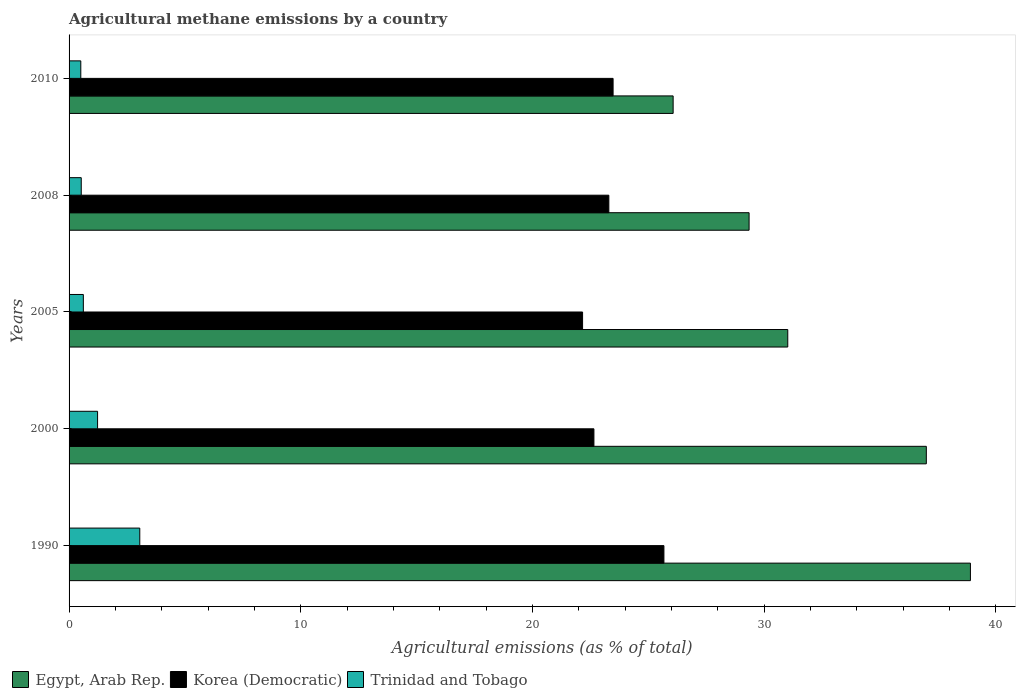Are the number of bars per tick equal to the number of legend labels?
Your answer should be compact. Yes. How many bars are there on the 2nd tick from the bottom?
Your answer should be very brief. 3. What is the amount of agricultural methane emitted in Egypt, Arab Rep. in 2010?
Ensure brevity in your answer.  26.07. Across all years, what is the maximum amount of agricultural methane emitted in Trinidad and Tobago?
Keep it short and to the point. 3.05. Across all years, what is the minimum amount of agricultural methane emitted in Korea (Democratic)?
Keep it short and to the point. 22.16. What is the total amount of agricultural methane emitted in Egypt, Arab Rep. in the graph?
Make the answer very short. 162.35. What is the difference between the amount of agricultural methane emitted in Korea (Democratic) in 2008 and that in 2010?
Ensure brevity in your answer.  -0.18. What is the difference between the amount of agricultural methane emitted in Korea (Democratic) in 1990 and the amount of agricultural methane emitted in Egypt, Arab Rep. in 2010?
Keep it short and to the point. -0.4. What is the average amount of agricultural methane emitted in Egypt, Arab Rep. per year?
Provide a succinct answer. 32.47. In the year 1990, what is the difference between the amount of agricultural methane emitted in Korea (Democratic) and amount of agricultural methane emitted in Trinidad and Tobago?
Provide a succinct answer. 22.62. What is the ratio of the amount of agricultural methane emitted in Egypt, Arab Rep. in 1990 to that in 2010?
Offer a terse response. 1.49. What is the difference between the highest and the second highest amount of agricultural methane emitted in Korea (Democratic)?
Keep it short and to the point. 2.19. What is the difference between the highest and the lowest amount of agricultural methane emitted in Korea (Democratic)?
Your response must be concise. 3.51. Is the sum of the amount of agricultural methane emitted in Korea (Democratic) in 1990 and 2008 greater than the maximum amount of agricultural methane emitted in Egypt, Arab Rep. across all years?
Provide a succinct answer. Yes. What does the 1st bar from the top in 2000 represents?
Your response must be concise. Trinidad and Tobago. What does the 2nd bar from the bottom in 2010 represents?
Keep it short and to the point. Korea (Democratic). How many bars are there?
Provide a succinct answer. 15. How many years are there in the graph?
Provide a short and direct response. 5. Are the values on the major ticks of X-axis written in scientific E-notation?
Provide a succinct answer. No. Does the graph contain any zero values?
Ensure brevity in your answer.  No. Does the graph contain grids?
Your response must be concise. No. What is the title of the graph?
Give a very brief answer. Agricultural methane emissions by a country. What is the label or title of the X-axis?
Make the answer very short. Agricultural emissions (as % of total). What is the Agricultural emissions (as % of total) in Egypt, Arab Rep. in 1990?
Provide a succinct answer. 38.9. What is the Agricultural emissions (as % of total) of Korea (Democratic) in 1990?
Ensure brevity in your answer.  25.68. What is the Agricultural emissions (as % of total) of Trinidad and Tobago in 1990?
Your answer should be very brief. 3.05. What is the Agricultural emissions (as % of total) of Egypt, Arab Rep. in 2000?
Offer a very short reply. 37. What is the Agricultural emissions (as % of total) in Korea (Democratic) in 2000?
Make the answer very short. 22.65. What is the Agricultural emissions (as % of total) of Trinidad and Tobago in 2000?
Your answer should be very brief. 1.23. What is the Agricultural emissions (as % of total) in Egypt, Arab Rep. in 2005?
Provide a short and direct response. 31.02. What is the Agricultural emissions (as % of total) of Korea (Democratic) in 2005?
Provide a short and direct response. 22.16. What is the Agricultural emissions (as % of total) in Trinidad and Tobago in 2005?
Keep it short and to the point. 0.62. What is the Agricultural emissions (as % of total) in Egypt, Arab Rep. in 2008?
Provide a short and direct response. 29.35. What is the Agricultural emissions (as % of total) of Korea (Democratic) in 2008?
Offer a very short reply. 23.3. What is the Agricultural emissions (as % of total) in Trinidad and Tobago in 2008?
Offer a terse response. 0.53. What is the Agricultural emissions (as % of total) in Egypt, Arab Rep. in 2010?
Your answer should be very brief. 26.07. What is the Agricultural emissions (as % of total) of Korea (Democratic) in 2010?
Give a very brief answer. 23.48. What is the Agricultural emissions (as % of total) of Trinidad and Tobago in 2010?
Offer a terse response. 0.51. Across all years, what is the maximum Agricultural emissions (as % of total) in Egypt, Arab Rep.?
Ensure brevity in your answer.  38.9. Across all years, what is the maximum Agricultural emissions (as % of total) in Korea (Democratic)?
Make the answer very short. 25.68. Across all years, what is the maximum Agricultural emissions (as % of total) of Trinidad and Tobago?
Give a very brief answer. 3.05. Across all years, what is the minimum Agricultural emissions (as % of total) of Egypt, Arab Rep.?
Offer a terse response. 26.07. Across all years, what is the minimum Agricultural emissions (as % of total) of Korea (Democratic)?
Make the answer very short. 22.16. Across all years, what is the minimum Agricultural emissions (as % of total) in Trinidad and Tobago?
Your answer should be very brief. 0.51. What is the total Agricultural emissions (as % of total) of Egypt, Arab Rep. in the graph?
Provide a succinct answer. 162.35. What is the total Agricultural emissions (as % of total) of Korea (Democratic) in the graph?
Your response must be concise. 117.27. What is the total Agricultural emissions (as % of total) of Trinidad and Tobago in the graph?
Your answer should be compact. 5.93. What is the difference between the Agricultural emissions (as % of total) of Egypt, Arab Rep. in 1990 and that in 2000?
Make the answer very short. 1.9. What is the difference between the Agricultural emissions (as % of total) in Korea (Democratic) in 1990 and that in 2000?
Offer a terse response. 3.02. What is the difference between the Agricultural emissions (as % of total) in Trinidad and Tobago in 1990 and that in 2000?
Provide a succinct answer. 1.82. What is the difference between the Agricultural emissions (as % of total) of Egypt, Arab Rep. in 1990 and that in 2005?
Make the answer very short. 7.88. What is the difference between the Agricultural emissions (as % of total) in Korea (Democratic) in 1990 and that in 2005?
Make the answer very short. 3.51. What is the difference between the Agricultural emissions (as % of total) in Trinidad and Tobago in 1990 and that in 2005?
Offer a very short reply. 2.44. What is the difference between the Agricultural emissions (as % of total) of Egypt, Arab Rep. in 1990 and that in 2008?
Ensure brevity in your answer.  9.55. What is the difference between the Agricultural emissions (as % of total) of Korea (Democratic) in 1990 and that in 2008?
Give a very brief answer. 2.38. What is the difference between the Agricultural emissions (as % of total) in Trinidad and Tobago in 1990 and that in 2008?
Your answer should be compact. 2.53. What is the difference between the Agricultural emissions (as % of total) in Egypt, Arab Rep. in 1990 and that in 2010?
Keep it short and to the point. 12.83. What is the difference between the Agricultural emissions (as % of total) in Korea (Democratic) in 1990 and that in 2010?
Your answer should be compact. 2.19. What is the difference between the Agricultural emissions (as % of total) of Trinidad and Tobago in 1990 and that in 2010?
Provide a short and direct response. 2.55. What is the difference between the Agricultural emissions (as % of total) of Egypt, Arab Rep. in 2000 and that in 2005?
Your response must be concise. 5.98. What is the difference between the Agricultural emissions (as % of total) of Korea (Democratic) in 2000 and that in 2005?
Offer a terse response. 0.49. What is the difference between the Agricultural emissions (as % of total) of Trinidad and Tobago in 2000 and that in 2005?
Provide a succinct answer. 0.61. What is the difference between the Agricultural emissions (as % of total) of Egypt, Arab Rep. in 2000 and that in 2008?
Your answer should be compact. 7.65. What is the difference between the Agricultural emissions (as % of total) in Korea (Democratic) in 2000 and that in 2008?
Provide a short and direct response. -0.64. What is the difference between the Agricultural emissions (as % of total) of Trinidad and Tobago in 2000 and that in 2008?
Offer a very short reply. 0.7. What is the difference between the Agricultural emissions (as % of total) in Egypt, Arab Rep. in 2000 and that in 2010?
Make the answer very short. 10.93. What is the difference between the Agricultural emissions (as % of total) in Korea (Democratic) in 2000 and that in 2010?
Provide a succinct answer. -0.83. What is the difference between the Agricultural emissions (as % of total) in Trinidad and Tobago in 2000 and that in 2010?
Offer a terse response. 0.72. What is the difference between the Agricultural emissions (as % of total) in Egypt, Arab Rep. in 2005 and that in 2008?
Keep it short and to the point. 1.67. What is the difference between the Agricultural emissions (as % of total) of Korea (Democratic) in 2005 and that in 2008?
Provide a succinct answer. -1.13. What is the difference between the Agricultural emissions (as % of total) of Trinidad and Tobago in 2005 and that in 2008?
Keep it short and to the point. 0.09. What is the difference between the Agricultural emissions (as % of total) in Egypt, Arab Rep. in 2005 and that in 2010?
Offer a terse response. 4.95. What is the difference between the Agricultural emissions (as % of total) in Korea (Democratic) in 2005 and that in 2010?
Ensure brevity in your answer.  -1.32. What is the difference between the Agricultural emissions (as % of total) in Trinidad and Tobago in 2005 and that in 2010?
Offer a very short reply. 0.11. What is the difference between the Agricultural emissions (as % of total) of Egypt, Arab Rep. in 2008 and that in 2010?
Make the answer very short. 3.28. What is the difference between the Agricultural emissions (as % of total) in Korea (Democratic) in 2008 and that in 2010?
Your answer should be very brief. -0.18. What is the difference between the Agricultural emissions (as % of total) in Trinidad and Tobago in 2008 and that in 2010?
Make the answer very short. 0.02. What is the difference between the Agricultural emissions (as % of total) of Egypt, Arab Rep. in 1990 and the Agricultural emissions (as % of total) of Korea (Democratic) in 2000?
Provide a succinct answer. 16.25. What is the difference between the Agricultural emissions (as % of total) of Egypt, Arab Rep. in 1990 and the Agricultural emissions (as % of total) of Trinidad and Tobago in 2000?
Provide a short and direct response. 37.67. What is the difference between the Agricultural emissions (as % of total) of Korea (Democratic) in 1990 and the Agricultural emissions (as % of total) of Trinidad and Tobago in 2000?
Ensure brevity in your answer.  24.44. What is the difference between the Agricultural emissions (as % of total) in Egypt, Arab Rep. in 1990 and the Agricultural emissions (as % of total) in Korea (Democratic) in 2005?
Your answer should be compact. 16.74. What is the difference between the Agricultural emissions (as % of total) in Egypt, Arab Rep. in 1990 and the Agricultural emissions (as % of total) in Trinidad and Tobago in 2005?
Keep it short and to the point. 38.29. What is the difference between the Agricultural emissions (as % of total) of Korea (Democratic) in 1990 and the Agricultural emissions (as % of total) of Trinidad and Tobago in 2005?
Offer a terse response. 25.06. What is the difference between the Agricultural emissions (as % of total) of Egypt, Arab Rep. in 1990 and the Agricultural emissions (as % of total) of Korea (Democratic) in 2008?
Your response must be concise. 15.61. What is the difference between the Agricultural emissions (as % of total) of Egypt, Arab Rep. in 1990 and the Agricultural emissions (as % of total) of Trinidad and Tobago in 2008?
Your answer should be very brief. 38.38. What is the difference between the Agricultural emissions (as % of total) of Korea (Democratic) in 1990 and the Agricultural emissions (as % of total) of Trinidad and Tobago in 2008?
Offer a very short reply. 25.15. What is the difference between the Agricultural emissions (as % of total) of Egypt, Arab Rep. in 1990 and the Agricultural emissions (as % of total) of Korea (Democratic) in 2010?
Provide a short and direct response. 15.42. What is the difference between the Agricultural emissions (as % of total) of Egypt, Arab Rep. in 1990 and the Agricultural emissions (as % of total) of Trinidad and Tobago in 2010?
Keep it short and to the point. 38.4. What is the difference between the Agricultural emissions (as % of total) of Korea (Democratic) in 1990 and the Agricultural emissions (as % of total) of Trinidad and Tobago in 2010?
Provide a short and direct response. 25.17. What is the difference between the Agricultural emissions (as % of total) of Egypt, Arab Rep. in 2000 and the Agricultural emissions (as % of total) of Korea (Democratic) in 2005?
Offer a very short reply. 14.84. What is the difference between the Agricultural emissions (as % of total) in Egypt, Arab Rep. in 2000 and the Agricultural emissions (as % of total) in Trinidad and Tobago in 2005?
Make the answer very short. 36.38. What is the difference between the Agricultural emissions (as % of total) in Korea (Democratic) in 2000 and the Agricultural emissions (as % of total) in Trinidad and Tobago in 2005?
Ensure brevity in your answer.  22.04. What is the difference between the Agricultural emissions (as % of total) in Egypt, Arab Rep. in 2000 and the Agricultural emissions (as % of total) in Korea (Democratic) in 2008?
Provide a succinct answer. 13.7. What is the difference between the Agricultural emissions (as % of total) in Egypt, Arab Rep. in 2000 and the Agricultural emissions (as % of total) in Trinidad and Tobago in 2008?
Your response must be concise. 36.48. What is the difference between the Agricultural emissions (as % of total) in Korea (Democratic) in 2000 and the Agricultural emissions (as % of total) in Trinidad and Tobago in 2008?
Offer a terse response. 22.13. What is the difference between the Agricultural emissions (as % of total) of Egypt, Arab Rep. in 2000 and the Agricultural emissions (as % of total) of Korea (Democratic) in 2010?
Provide a short and direct response. 13.52. What is the difference between the Agricultural emissions (as % of total) in Egypt, Arab Rep. in 2000 and the Agricultural emissions (as % of total) in Trinidad and Tobago in 2010?
Offer a terse response. 36.49. What is the difference between the Agricultural emissions (as % of total) in Korea (Democratic) in 2000 and the Agricultural emissions (as % of total) in Trinidad and Tobago in 2010?
Provide a succinct answer. 22.15. What is the difference between the Agricultural emissions (as % of total) in Egypt, Arab Rep. in 2005 and the Agricultural emissions (as % of total) in Korea (Democratic) in 2008?
Make the answer very short. 7.72. What is the difference between the Agricultural emissions (as % of total) in Egypt, Arab Rep. in 2005 and the Agricultural emissions (as % of total) in Trinidad and Tobago in 2008?
Ensure brevity in your answer.  30.49. What is the difference between the Agricultural emissions (as % of total) in Korea (Democratic) in 2005 and the Agricultural emissions (as % of total) in Trinidad and Tobago in 2008?
Your answer should be very brief. 21.64. What is the difference between the Agricultural emissions (as % of total) in Egypt, Arab Rep. in 2005 and the Agricultural emissions (as % of total) in Korea (Democratic) in 2010?
Give a very brief answer. 7.54. What is the difference between the Agricultural emissions (as % of total) in Egypt, Arab Rep. in 2005 and the Agricultural emissions (as % of total) in Trinidad and Tobago in 2010?
Ensure brevity in your answer.  30.51. What is the difference between the Agricultural emissions (as % of total) of Korea (Democratic) in 2005 and the Agricultural emissions (as % of total) of Trinidad and Tobago in 2010?
Offer a terse response. 21.66. What is the difference between the Agricultural emissions (as % of total) in Egypt, Arab Rep. in 2008 and the Agricultural emissions (as % of total) in Korea (Democratic) in 2010?
Keep it short and to the point. 5.87. What is the difference between the Agricultural emissions (as % of total) in Egypt, Arab Rep. in 2008 and the Agricultural emissions (as % of total) in Trinidad and Tobago in 2010?
Provide a short and direct response. 28.84. What is the difference between the Agricultural emissions (as % of total) in Korea (Democratic) in 2008 and the Agricultural emissions (as % of total) in Trinidad and Tobago in 2010?
Your answer should be very brief. 22.79. What is the average Agricultural emissions (as % of total) in Egypt, Arab Rep. per year?
Your response must be concise. 32.47. What is the average Agricultural emissions (as % of total) in Korea (Democratic) per year?
Make the answer very short. 23.45. What is the average Agricultural emissions (as % of total) of Trinidad and Tobago per year?
Provide a succinct answer. 1.19. In the year 1990, what is the difference between the Agricultural emissions (as % of total) of Egypt, Arab Rep. and Agricultural emissions (as % of total) of Korea (Democratic)?
Your answer should be compact. 13.23. In the year 1990, what is the difference between the Agricultural emissions (as % of total) of Egypt, Arab Rep. and Agricultural emissions (as % of total) of Trinidad and Tobago?
Give a very brief answer. 35.85. In the year 1990, what is the difference between the Agricultural emissions (as % of total) of Korea (Democratic) and Agricultural emissions (as % of total) of Trinidad and Tobago?
Provide a short and direct response. 22.62. In the year 2000, what is the difference between the Agricultural emissions (as % of total) of Egypt, Arab Rep. and Agricultural emissions (as % of total) of Korea (Democratic)?
Make the answer very short. 14.35. In the year 2000, what is the difference between the Agricultural emissions (as % of total) of Egypt, Arab Rep. and Agricultural emissions (as % of total) of Trinidad and Tobago?
Offer a very short reply. 35.77. In the year 2000, what is the difference between the Agricultural emissions (as % of total) in Korea (Democratic) and Agricultural emissions (as % of total) in Trinidad and Tobago?
Keep it short and to the point. 21.42. In the year 2005, what is the difference between the Agricultural emissions (as % of total) of Egypt, Arab Rep. and Agricultural emissions (as % of total) of Korea (Democratic)?
Give a very brief answer. 8.86. In the year 2005, what is the difference between the Agricultural emissions (as % of total) in Egypt, Arab Rep. and Agricultural emissions (as % of total) in Trinidad and Tobago?
Your answer should be compact. 30.4. In the year 2005, what is the difference between the Agricultural emissions (as % of total) in Korea (Democratic) and Agricultural emissions (as % of total) in Trinidad and Tobago?
Your answer should be very brief. 21.55. In the year 2008, what is the difference between the Agricultural emissions (as % of total) in Egypt, Arab Rep. and Agricultural emissions (as % of total) in Korea (Democratic)?
Provide a short and direct response. 6.05. In the year 2008, what is the difference between the Agricultural emissions (as % of total) of Egypt, Arab Rep. and Agricultural emissions (as % of total) of Trinidad and Tobago?
Provide a succinct answer. 28.83. In the year 2008, what is the difference between the Agricultural emissions (as % of total) of Korea (Democratic) and Agricultural emissions (as % of total) of Trinidad and Tobago?
Your answer should be very brief. 22.77. In the year 2010, what is the difference between the Agricultural emissions (as % of total) of Egypt, Arab Rep. and Agricultural emissions (as % of total) of Korea (Democratic)?
Offer a terse response. 2.59. In the year 2010, what is the difference between the Agricultural emissions (as % of total) in Egypt, Arab Rep. and Agricultural emissions (as % of total) in Trinidad and Tobago?
Ensure brevity in your answer.  25.57. In the year 2010, what is the difference between the Agricultural emissions (as % of total) of Korea (Democratic) and Agricultural emissions (as % of total) of Trinidad and Tobago?
Keep it short and to the point. 22.97. What is the ratio of the Agricultural emissions (as % of total) of Egypt, Arab Rep. in 1990 to that in 2000?
Give a very brief answer. 1.05. What is the ratio of the Agricultural emissions (as % of total) in Korea (Democratic) in 1990 to that in 2000?
Ensure brevity in your answer.  1.13. What is the ratio of the Agricultural emissions (as % of total) of Trinidad and Tobago in 1990 to that in 2000?
Keep it short and to the point. 2.48. What is the ratio of the Agricultural emissions (as % of total) of Egypt, Arab Rep. in 1990 to that in 2005?
Your answer should be compact. 1.25. What is the ratio of the Agricultural emissions (as % of total) in Korea (Democratic) in 1990 to that in 2005?
Your answer should be compact. 1.16. What is the ratio of the Agricultural emissions (as % of total) of Trinidad and Tobago in 1990 to that in 2005?
Your response must be concise. 4.95. What is the ratio of the Agricultural emissions (as % of total) in Egypt, Arab Rep. in 1990 to that in 2008?
Your answer should be compact. 1.33. What is the ratio of the Agricultural emissions (as % of total) in Korea (Democratic) in 1990 to that in 2008?
Your answer should be very brief. 1.1. What is the ratio of the Agricultural emissions (as % of total) in Trinidad and Tobago in 1990 to that in 2008?
Provide a short and direct response. 5.81. What is the ratio of the Agricultural emissions (as % of total) of Egypt, Arab Rep. in 1990 to that in 2010?
Keep it short and to the point. 1.49. What is the ratio of the Agricultural emissions (as % of total) in Korea (Democratic) in 1990 to that in 2010?
Make the answer very short. 1.09. What is the ratio of the Agricultural emissions (as % of total) of Trinidad and Tobago in 1990 to that in 2010?
Keep it short and to the point. 6.03. What is the ratio of the Agricultural emissions (as % of total) of Egypt, Arab Rep. in 2000 to that in 2005?
Your answer should be compact. 1.19. What is the ratio of the Agricultural emissions (as % of total) of Korea (Democratic) in 2000 to that in 2005?
Make the answer very short. 1.02. What is the ratio of the Agricultural emissions (as % of total) in Trinidad and Tobago in 2000 to that in 2005?
Your response must be concise. 2. What is the ratio of the Agricultural emissions (as % of total) in Egypt, Arab Rep. in 2000 to that in 2008?
Your answer should be very brief. 1.26. What is the ratio of the Agricultural emissions (as % of total) in Korea (Democratic) in 2000 to that in 2008?
Your response must be concise. 0.97. What is the ratio of the Agricultural emissions (as % of total) in Trinidad and Tobago in 2000 to that in 2008?
Make the answer very short. 2.34. What is the ratio of the Agricultural emissions (as % of total) of Egypt, Arab Rep. in 2000 to that in 2010?
Your answer should be compact. 1.42. What is the ratio of the Agricultural emissions (as % of total) of Korea (Democratic) in 2000 to that in 2010?
Provide a short and direct response. 0.96. What is the ratio of the Agricultural emissions (as % of total) in Trinidad and Tobago in 2000 to that in 2010?
Provide a short and direct response. 2.43. What is the ratio of the Agricultural emissions (as % of total) of Egypt, Arab Rep. in 2005 to that in 2008?
Provide a short and direct response. 1.06. What is the ratio of the Agricultural emissions (as % of total) in Korea (Democratic) in 2005 to that in 2008?
Offer a terse response. 0.95. What is the ratio of the Agricultural emissions (as % of total) of Trinidad and Tobago in 2005 to that in 2008?
Your response must be concise. 1.17. What is the ratio of the Agricultural emissions (as % of total) of Egypt, Arab Rep. in 2005 to that in 2010?
Give a very brief answer. 1.19. What is the ratio of the Agricultural emissions (as % of total) of Korea (Democratic) in 2005 to that in 2010?
Offer a terse response. 0.94. What is the ratio of the Agricultural emissions (as % of total) of Trinidad and Tobago in 2005 to that in 2010?
Offer a very short reply. 1.22. What is the ratio of the Agricultural emissions (as % of total) of Egypt, Arab Rep. in 2008 to that in 2010?
Offer a terse response. 1.13. What is the ratio of the Agricultural emissions (as % of total) of Korea (Democratic) in 2008 to that in 2010?
Give a very brief answer. 0.99. What is the ratio of the Agricultural emissions (as % of total) in Trinidad and Tobago in 2008 to that in 2010?
Offer a very short reply. 1.04. What is the difference between the highest and the second highest Agricultural emissions (as % of total) in Egypt, Arab Rep.?
Provide a short and direct response. 1.9. What is the difference between the highest and the second highest Agricultural emissions (as % of total) in Korea (Democratic)?
Offer a terse response. 2.19. What is the difference between the highest and the second highest Agricultural emissions (as % of total) of Trinidad and Tobago?
Ensure brevity in your answer.  1.82. What is the difference between the highest and the lowest Agricultural emissions (as % of total) of Egypt, Arab Rep.?
Offer a terse response. 12.83. What is the difference between the highest and the lowest Agricultural emissions (as % of total) in Korea (Democratic)?
Provide a succinct answer. 3.51. What is the difference between the highest and the lowest Agricultural emissions (as % of total) of Trinidad and Tobago?
Provide a succinct answer. 2.55. 